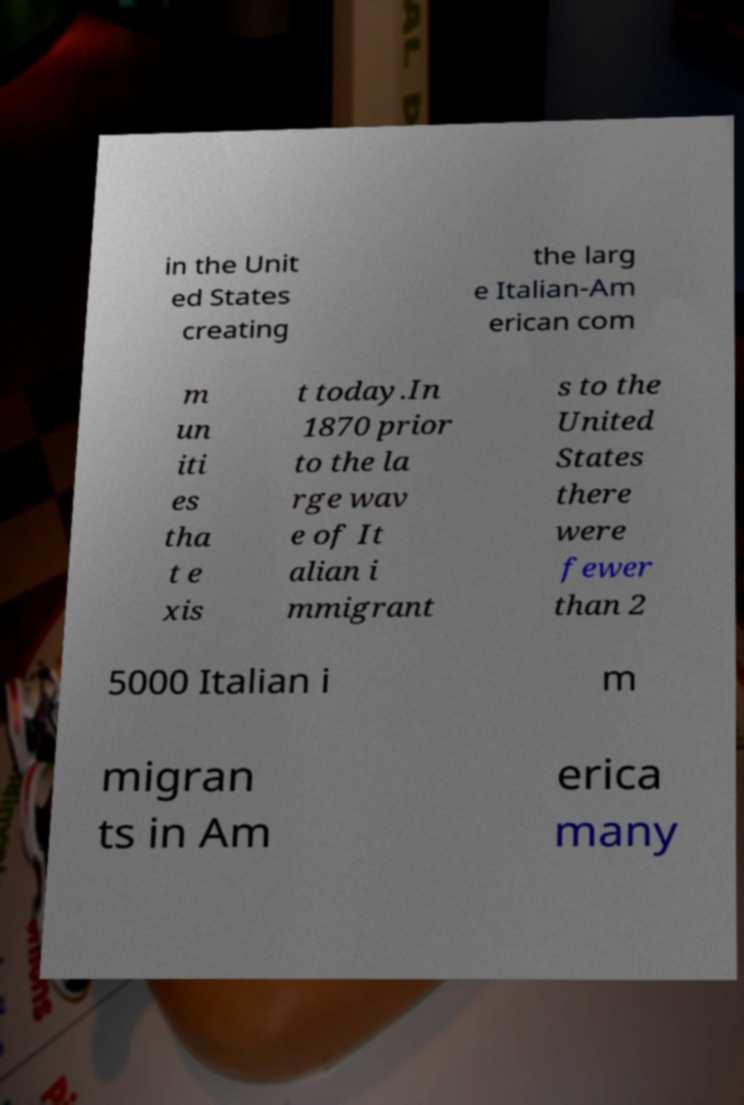Please read and relay the text visible in this image. What does it say? in the Unit ed States creating the larg e Italian-Am erican com m un iti es tha t e xis t today.In 1870 prior to the la rge wav e of It alian i mmigrant s to the United States there were fewer than 2 5000 Italian i m migran ts in Am erica many 